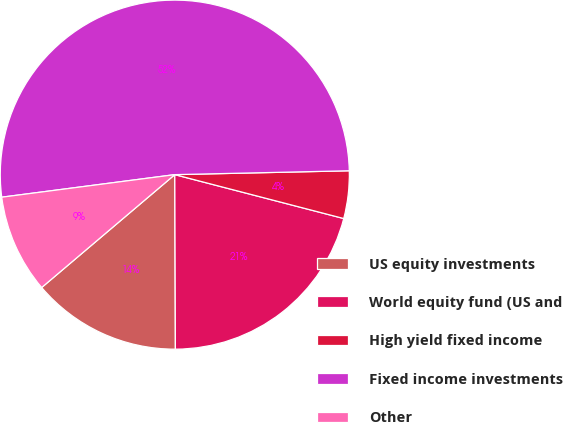Convert chart. <chart><loc_0><loc_0><loc_500><loc_500><pie_chart><fcel>US equity investments<fcel>World equity fund (US and<fcel>High yield fixed income<fcel>Fixed income investments<fcel>Other<nl><fcel>13.86%<fcel>20.9%<fcel>4.4%<fcel>51.71%<fcel>9.13%<nl></chart> 